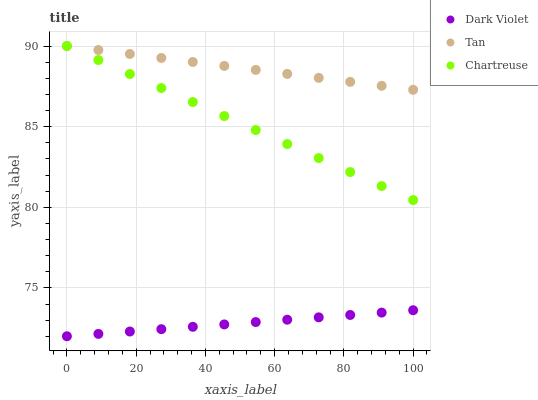Does Dark Violet have the minimum area under the curve?
Answer yes or no. Yes. Does Tan have the maximum area under the curve?
Answer yes or no. Yes. Does Chartreuse have the minimum area under the curve?
Answer yes or no. No. Does Chartreuse have the maximum area under the curve?
Answer yes or no. No. Is Chartreuse the smoothest?
Answer yes or no. Yes. Is Tan the roughest?
Answer yes or no. Yes. Is Dark Violet the smoothest?
Answer yes or no. No. Is Dark Violet the roughest?
Answer yes or no. No. Does Dark Violet have the lowest value?
Answer yes or no. Yes. Does Chartreuse have the lowest value?
Answer yes or no. No. Does Chartreuse have the highest value?
Answer yes or no. Yes. Does Dark Violet have the highest value?
Answer yes or no. No. Is Dark Violet less than Tan?
Answer yes or no. Yes. Is Tan greater than Dark Violet?
Answer yes or no. Yes. Does Chartreuse intersect Tan?
Answer yes or no. Yes. Is Chartreuse less than Tan?
Answer yes or no. No. Is Chartreuse greater than Tan?
Answer yes or no. No. Does Dark Violet intersect Tan?
Answer yes or no. No. 